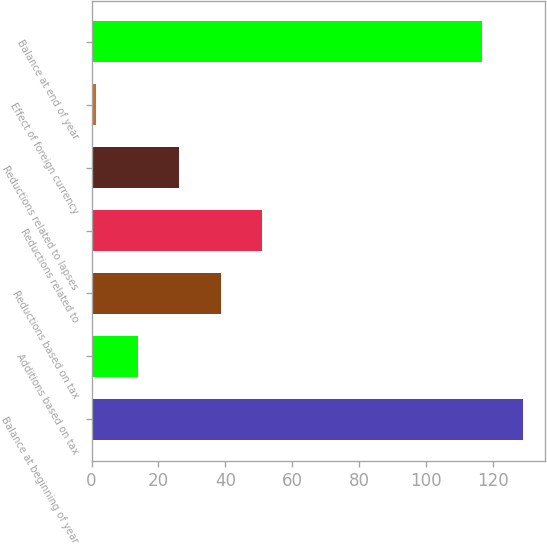<chart> <loc_0><loc_0><loc_500><loc_500><bar_chart><fcel>Balance at beginning of year<fcel>Additions based on tax<fcel>Reductions based on tax<fcel>Reductions related to<fcel>Reductions related to lapses<fcel>Effect of foreign currency<fcel>Balance at end of year<nl><fcel>129.15<fcel>13.75<fcel>38.65<fcel>51.1<fcel>26.2<fcel>1.3<fcel>116.7<nl></chart> 